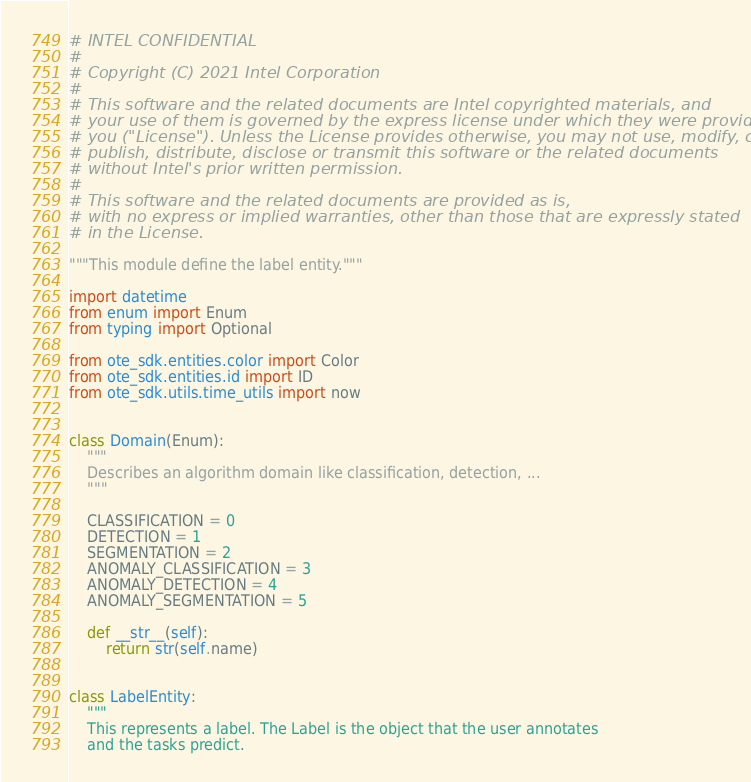<code> <loc_0><loc_0><loc_500><loc_500><_Python_># INTEL CONFIDENTIAL
#
# Copyright (C) 2021 Intel Corporation
#
# This software and the related documents are Intel copyrighted materials, and
# your use of them is governed by the express license under which they were provided to
# you ("License"). Unless the License provides otherwise, you may not use, modify, copy,
# publish, distribute, disclose or transmit this software or the related documents
# without Intel's prior written permission.
#
# This software and the related documents are provided as is,
# with no express or implied warranties, other than those that are expressly stated
# in the License.

"""This module define the label entity."""

import datetime
from enum import Enum
from typing import Optional

from ote_sdk.entities.color import Color
from ote_sdk.entities.id import ID
from ote_sdk.utils.time_utils import now


class Domain(Enum):
    """
    Describes an algorithm domain like classification, detection, ...
    """

    CLASSIFICATION = 0
    DETECTION = 1
    SEGMENTATION = 2
    ANOMALY_CLASSIFICATION = 3
    ANOMALY_DETECTION = 4
    ANOMALY_SEGMENTATION = 5

    def __str__(self):
        return str(self.name)


class LabelEntity:
    """
    This represents a label. The Label is the object that the user annotates
    and the tasks predict.
</code> 